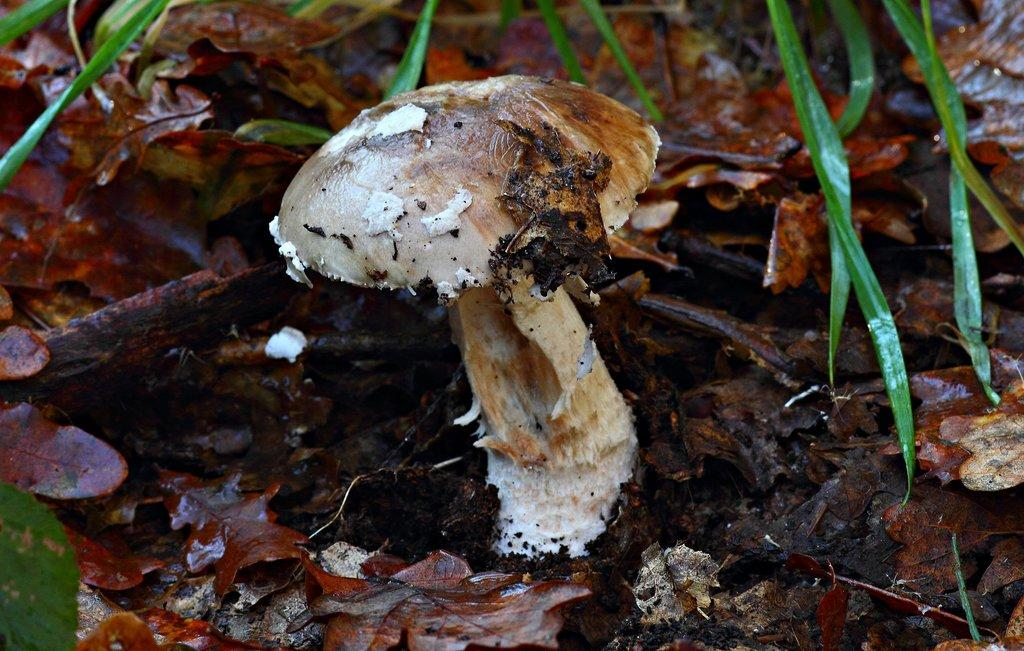What is the main object in the image that resembles a mushroom? There is a mushroom-like object in the image. What other natural elements can be seen in the image? There are dried leaves visible in the image. Based on the appearance of the image, what type of environment might it depict? The image likely contains grass, but this is a speculative statement and not a definitive fact. Can you see a trail of footprints leading to the mushroom-like object in the image? There is no trail of footprints visible in the image. Are there any toes visible in the image? There are no toes present in the image. Is the mushroom-like object located on a seashore in the image? There is no indication of a seashore in the image; it appears to be a land-based environment. 